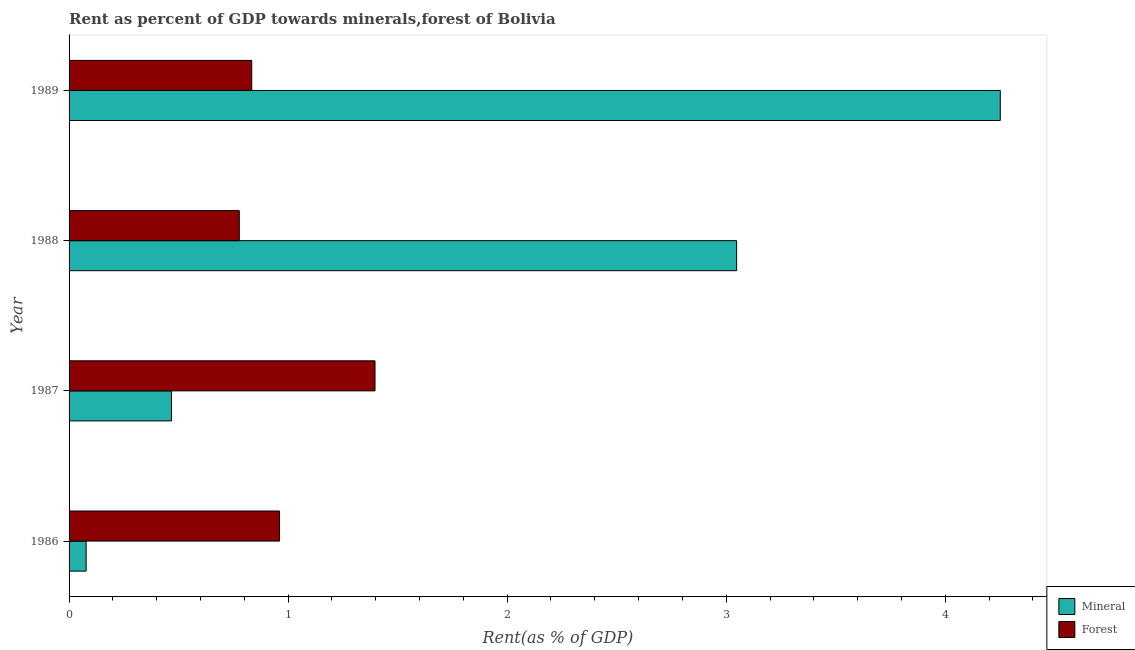How many groups of bars are there?
Offer a terse response. 4. Are the number of bars per tick equal to the number of legend labels?
Your answer should be compact. Yes. How many bars are there on the 3rd tick from the top?
Ensure brevity in your answer.  2. What is the label of the 2nd group of bars from the top?
Your answer should be very brief. 1988. In how many cases, is the number of bars for a given year not equal to the number of legend labels?
Keep it short and to the point. 0. What is the forest rent in 1989?
Offer a terse response. 0.83. Across all years, what is the maximum forest rent?
Offer a terse response. 1.4. Across all years, what is the minimum mineral rent?
Offer a very short reply. 0.08. What is the total mineral rent in the graph?
Provide a succinct answer. 7.84. What is the difference between the mineral rent in 1986 and that in 1987?
Ensure brevity in your answer.  -0.39. What is the difference between the forest rent in 1988 and the mineral rent in 1986?
Your answer should be very brief. 0.7. What is the average mineral rent per year?
Offer a terse response. 1.96. In the year 1989, what is the difference between the forest rent and mineral rent?
Your answer should be compact. -3.42. In how many years, is the forest rent greater than 1 %?
Give a very brief answer. 1. What is the ratio of the mineral rent in 1987 to that in 1989?
Your answer should be very brief. 0.11. Is the difference between the forest rent in 1987 and 1989 greater than the difference between the mineral rent in 1987 and 1989?
Provide a short and direct response. Yes. What is the difference between the highest and the second highest mineral rent?
Offer a terse response. 1.2. What is the difference between the highest and the lowest mineral rent?
Your answer should be compact. 4.17. Is the sum of the forest rent in 1987 and 1988 greater than the maximum mineral rent across all years?
Provide a short and direct response. No. What does the 1st bar from the top in 1986 represents?
Your response must be concise. Forest. What does the 1st bar from the bottom in 1988 represents?
Your answer should be very brief. Mineral. How many bars are there?
Provide a succinct answer. 8. What is the difference between two consecutive major ticks on the X-axis?
Your answer should be compact. 1. Are the values on the major ticks of X-axis written in scientific E-notation?
Provide a short and direct response. No. Does the graph contain any zero values?
Your response must be concise. No. Does the graph contain grids?
Ensure brevity in your answer.  No. Where does the legend appear in the graph?
Offer a very short reply. Bottom right. How are the legend labels stacked?
Offer a very short reply. Vertical. What is the title of the graph?
Ensure brevity in your answer.  Rent as percent of GDP towards minerals,forest of Bolivia. What is the label or title of the X-axis?
Provide a short and direct response. Rent(as % of GDP). What is the label or title of the Y-axis?
Provide a short and direct response. Year. What is the Rent(as % of GDP) of Mineral in 1986?
Make the answer very short. 0.08. What is the Rent(as % of GDP) in Forest in 1986?
Keep it short and to the point. 0.96. What is the Rent(as % of GDP) in Mineral in 1987?
Your answer should be very brief. 0.47. What is the Rent(as % of GDP) of Forest in 1987?
Offer a very short reply. 1.4. What is the Rent(as % of GDP) of Mineral in 1988?
Your answer should be very brief. 3.05. What is the Rent(as % of GDP) of Forest in 1988?
Offer a terse response. 0.78. What is the Rent(as % of GDP) of Mineral in 1989?
Make the answer very short. 4.25. What is the Rent(as % of GDP) in Forest in 1989?
Your answer should be very brief. 0.83. Across all years, what is the maximum Rent(as % of GDP) in Mineral?
Give a very brief answer. 4.25. Across all years, what is the maximum Rent(as % of GDP) of Forest?
Provide a short and direct response. 1.4. Across all years, what is the minimum Rent(as % of GDP) in Mineral?
Ensure brevity in your answer.  0.08. Across all years, what is the minimum Rent(as % of GDP) in Forest?
Offer a terse response. 0.78. What is the total Rent(as % of GDP) in Mineral in the graph?
Your answer should be compact. 7.84. What is the total Rent(as % of GDP) of Forest in the graph?
Your answer should be very brief. 3.97. What is the difference between the Rent(as % of GDP) in Mineral in 1986 and that in 1987?
Offer a very short reply. -0.39. What is the difference between the Rent(as % of GDP) in Forest in 1986 and that in 1987?
Offer a very short reply. -0.44. What is the difference between the Rent(as % of GDP) of Mineral in 1986 and that in 1988?
Ensure brevity in your answer.  -2.97. What is the difference between the Rent(as % of GDP) of Forest in 1986 and that in 1988?
Ensure brevity in your answer.  0.18. What is the difference between the Rent(as % of GDP) in Mineral in 1986 and that in 1989?
Provide a short and direct response. -4.17. What is the difference between the Rent(as % of GDP) of Forest in 1986 and that in 1989?
Your answer should be compact. 0.13. What is the difference between the Rent(as % of GDP) in Mineral in 1987 and that in 1988?
Your answer should be compact. -2.58. What is the difference between the Rent(as % of GDP) in Forest in 1987 and that in 1988?
Offer a very short reply. 0.62. What is the difference between the Rent(as % of GDP) in Mineral in 1987 and that in 1989?
Make the answer very short. -3.78. What is the difference between the Rent(as % of GDP) of Forest in 1987 and that in 1989?
Provide a short and direct response. 0.56. What is the difference between the Rent(as % of GDP) in Mineral in 1988 and that in 1989?
Keep it short and to the point. -1.2. What is the difference between the Rent(as % of GDP) of Forest in 1988 and that in 1989?
Ensure brevity in your answer.  -0.06. What is the difference between the Rent(as % of GDP) of Mineral in 1986 and the Rent(as % of GDP) of Forest in 1987?
Provide a succinct answer. -1.32. What is the difference between the Rent(as % of GDP) in Mineral in 1986 and the Rent(as % of GDP) in Forest in 1988?
Your answer should be compact. -0.7. What is the difference between the Rent(as % of GDP) in Mineral in 1986 and the Rent(as % of GDP) in Forest in 1989?
Your response must be concise. -0.76. What is the difference between the Rent(as % of GDP) in Mineral in 1987 and the Rent(as % of GDP) in Forest in 1988?
Offer a very short reply. -0.31. What is the difference between the Rent(as % of GDP) of Mineral in 1987 and the Rent(as % of GDP) of Forest in 1989?
Ensure brevity in your answer.  -0.37. What is the difference between the Rent(as % of GDP) of Mineral in 1988 and the Rent(as % of GDP) of Forest in 1989?
Your answer should be compact. 2.21. What is the average Rent(as % of GDP) of Mineral per year?
Keep it short and to the point. 1.96. What is the average Rent(as % of GDP) of Forest per year?
Make the answer very short. 0.99. In the year 1986, what is the difference between the Rent(as % of GDP) of Mineral and Rent(as % of GDP) of Forest?
Provide a succinct answer. -0.88. In the year 1987, what is the difference between the Rent(as % of GDP) of Mineral and Rent(as % of GDP) of Forest?
Ensure brevity in your answer.  -0.93. In the year 1988, what is the difference between the Rent(as % of GDP) in Mineral and Rent(as % of GDP) in Forest?
Make the answer very short. 2.27. In the year 1989, what is the difference between the Rent(as % of GDP) of Mineral and Rent(as % of GDP) of Forest?
Provide a short and direct response. 3.42. What is the ratio of the Rent(as % of GDP) of Mineral in 1986 to that in 1987?
Offer a very short reply. 0.17. What is the ratio of the Rent(as % of GDP) of Forest in 1986 to that in 1987?
Your response must be concise. 0.69. What is the ratio of the Rent(as % of GDP) in Mineral in 1986 to that in 1988?
Offer a very short reply. 0.03. What is the ratio of the Rent(as % of GDP) of Forest in 1986 to that in 1988?
Provide a short and direct response. 1.24. What is the ratio of the Rent(as % of GDP) in Mineral in 1986 to that in 1989?
Offer a very short reply. 0.02. What is the ratio of the Rent(as % of GDP) of Forest in 1986 to that in 1989?
Your response must be concise. 1.15. What is the ratio of the Rent(as % of GDP) in Mineral in 1987 to that in 1988?
Ensure brevity in your answer.  0.15. What is the ratio of the Rent(as % of GDP) of Forest in 1987 to that in 1988?
Your answer should be very brief. 1.8. What is the ratio of the Rent(as % of GDP) of Mineral in 1987 to that in 1989?
Ensure brevity in your answer.  0.11. What is the ratio of the Rent(as % of GDP) of Forest in 1987 to that in 1989?
Your answer should be compact. 1.67. What is the ratio of the Rent(as % of GDP) in Mineral in 1988 to that in 1989?
Make the answer very short. 0.72. What is the ratio of the Rent(as % of GDP) of Forest in 1988 to that in 1989?
Provide a short and direct response. 0.93. What is the difference between the highest and the second highest Rent(as % of GDP) in Mineral?
Your answer should be compact. 1.2. What is the difference between the highest and the second highest Rent(as % of GDP) in Forest?
Ensure brevity in your answer.  0.44. What is the difference between the highest and the lowest Rent(as % of GDP) of Mineral?
Provide a short and direct response. 4.17. What is the difference between the highest and the lowest Rent(as % of GDP) of Forest?
Provide a short and direct response. 0.62. 